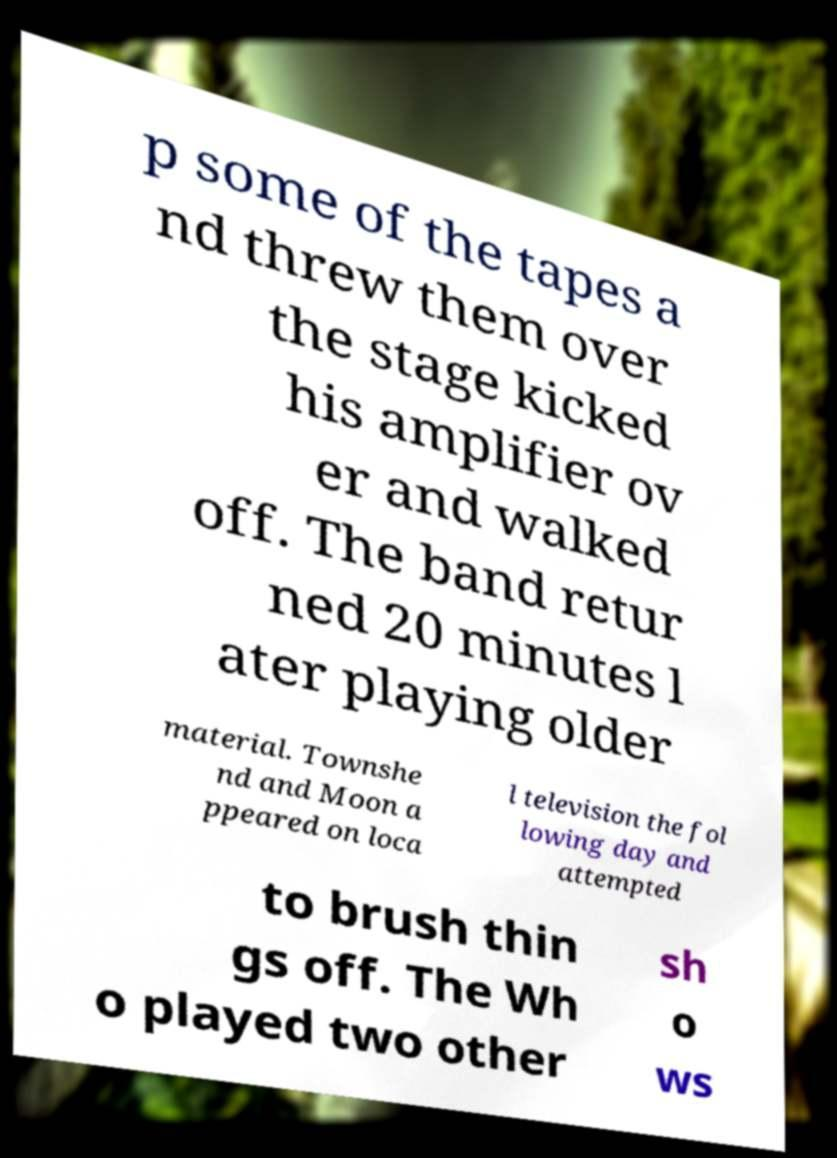Please read and relay the text visible in this image. What does it say? p some of the tapes a nd threw them over the stage kicked his amplifier ov er and walked off. The band retur ned 20 minutes l ater playing older material. Townshe nd and Moon a ppeared on loca l television the fol lowing day and attempted to brush thin gs off. The Wh o played two other sh o ws 